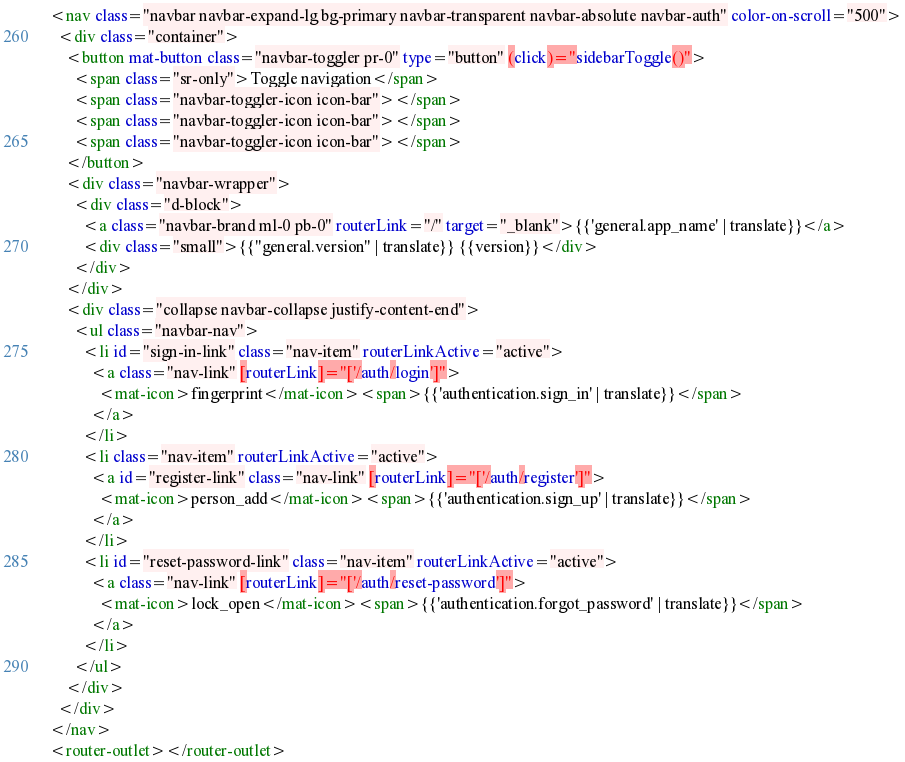Convert code to text. <code><loc_0><loc_0><loc_500><loc_500><_HTML_><nav class="navbar navbar-expand-lg bg-primary navbar-transparent navbar-absolute navbar-auth" color-on-scroll="500">
  <div class="container">
    <button mat-button class="navbar-toggler pr-0" type="button" (click)="sidebarToggle()">
      <span class="sr-only">Toggle navigation</span>
      <span class="navbar-toggler-icon icon-bar"></span>
      <span class="navbar-toggler-icon icon-bar"></span>
      <span class="navbar-toggler-icon icon-bar"></span>
    </button>
    <div class="navbar-wrapper">
      <div class="d-block">
        <a class="navbar-brand ml-0 pb-0" routerLink="/" target="_blank">{{'general.app_name' | translate}}</a>
        <div class="small">{{"general.version" | translate}} {{version}}</div>
      </div>
    </div>
    <div class="collapse navbar-collapse justify-content-end">
      <ul class="navbar-nav">
        <li id="sign-in-link" class="nav-item" routerLinkActive="active">
          <a class="nav-link" [routerLink]="['/auth/login']">
            <mat-icon>fingerprint</mat-icon><span>{{'authentication.sign_in' | translate}}</span>
          </a>
        </li>
        <li class="nav-item" routerLinkActive="active">
          <a id="register-link" class="nav-link" [routerLink]="['/auth/register']">
            <mat-icon>person_add</mat-icon><span>{{'authentication.sign_up' | translate}}</span>
          </a>
        </li>
        <li id="reset-password-link" class="nav-item" routerLinkActive="active">
          <a class="nav-link" [routerLink]="['/auth/reset-password']">
            <mat-icon>lock_open</mat-icon><span>{{'authentication.forgot_password' | translate}}</span>
          </a>
        </li>
      </ul>
    </div>
  </div>
</nav>
<router-outlet></router-outlet>
</code> 